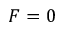Convert formula to latex. <formula><loc_0><loc_0><loc_500><loc_500>F = 0</formula> 